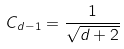<formula> <loc_0><loc_0><loc_500><loc_500>C _ { d - 1 } = \frac { 1 } { \sqrt { d + 2 } }</formula> 